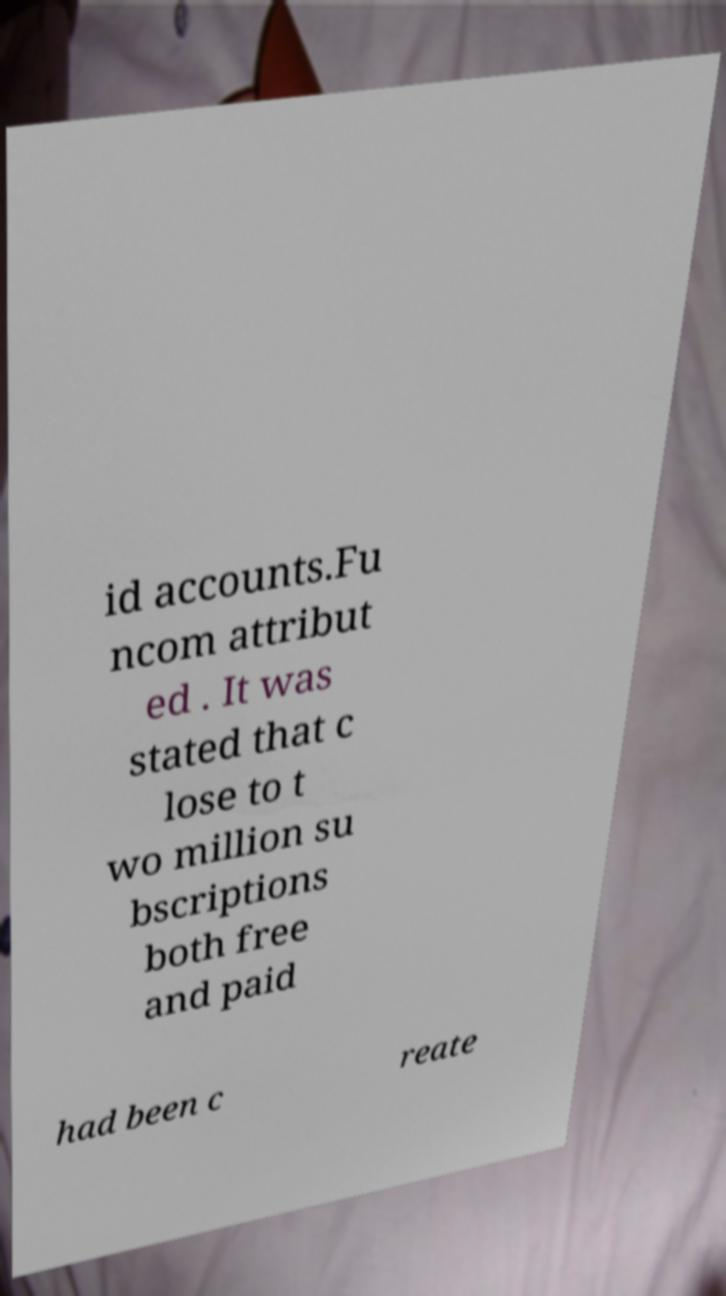Please identify and transcribe the text found in this image. id accounts.Fu ncom attribut ed . It was stated that c lose to t wo million su bscriptions both free and paid had been c reate 